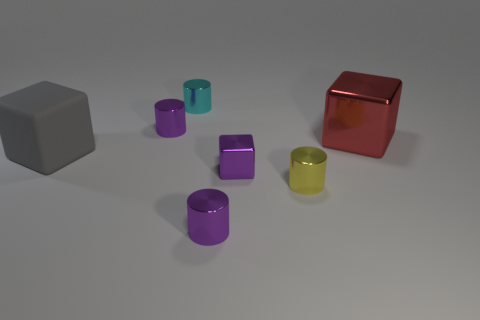Is the number of purple cylinders greater than the number of small cyan things?
Give a very brief answer. Yes. There is a purple metal cylinder in front of the big block that is on the right side of the small yellow shiny cylinder; is there a gray object in front of it?
Give a very brief answer. No. How many other things are the same size as the red block?
Keep it short and to the point. 1. Are there any purple things behind the big red object?
Your answer should be compact. Yes. Does the large rubber thing have the same color as the big thing to the right of the cyan metal cylinder?
Provide a succinct answer. No. There is a block that is behind the big object that is to the left of the metal cube left of the yellow metal thing; what color is it?
Your answer should be very brief. Red. Is there a purple thing that has the same shape as the small yellow object?
Ensure brevity in your answer.  Yes. What color is the rubber thing that is the same size as the red shiny thing?
Provide a succinct answer. Gray. What material is the large cube that is behind the gray block?
Make the answer very short. Metal. There is a tiny purple metal thing to the left of the small cyan cylinder; is its shape the same as the big object that is in front of the red object?
Give a very brief answer. No. 